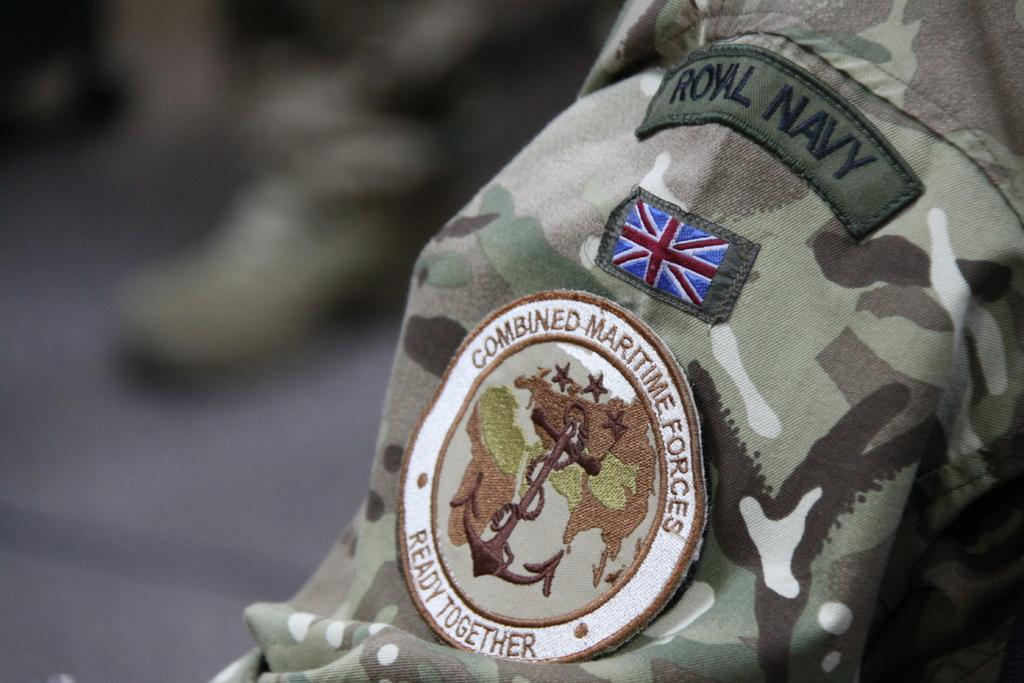What is featured on the army dress in the image? There is a logo on an army dress in the image. What type of magic is being performed by the person wearing the army dress in the image? There is no indication of magic or any performance in the image; it simply shows a logo on an army dress. 